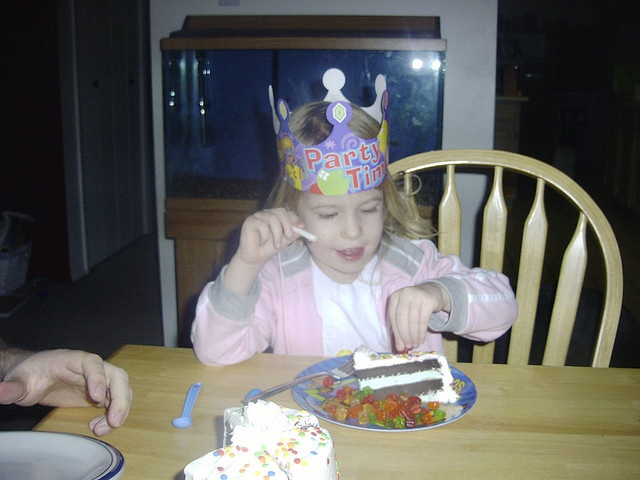Describe the objects in this image and their specific colors. I can see dining table in black, olive, darkgray, white, and gray tones, people in black, lavender, darkgray, and gray tones, chair in black, darkgray, tan, and lightgray tones, cake in black, white, khaki, darkgray, and lightpink tones, and people in black, darkgray, and gray tones in this image. 